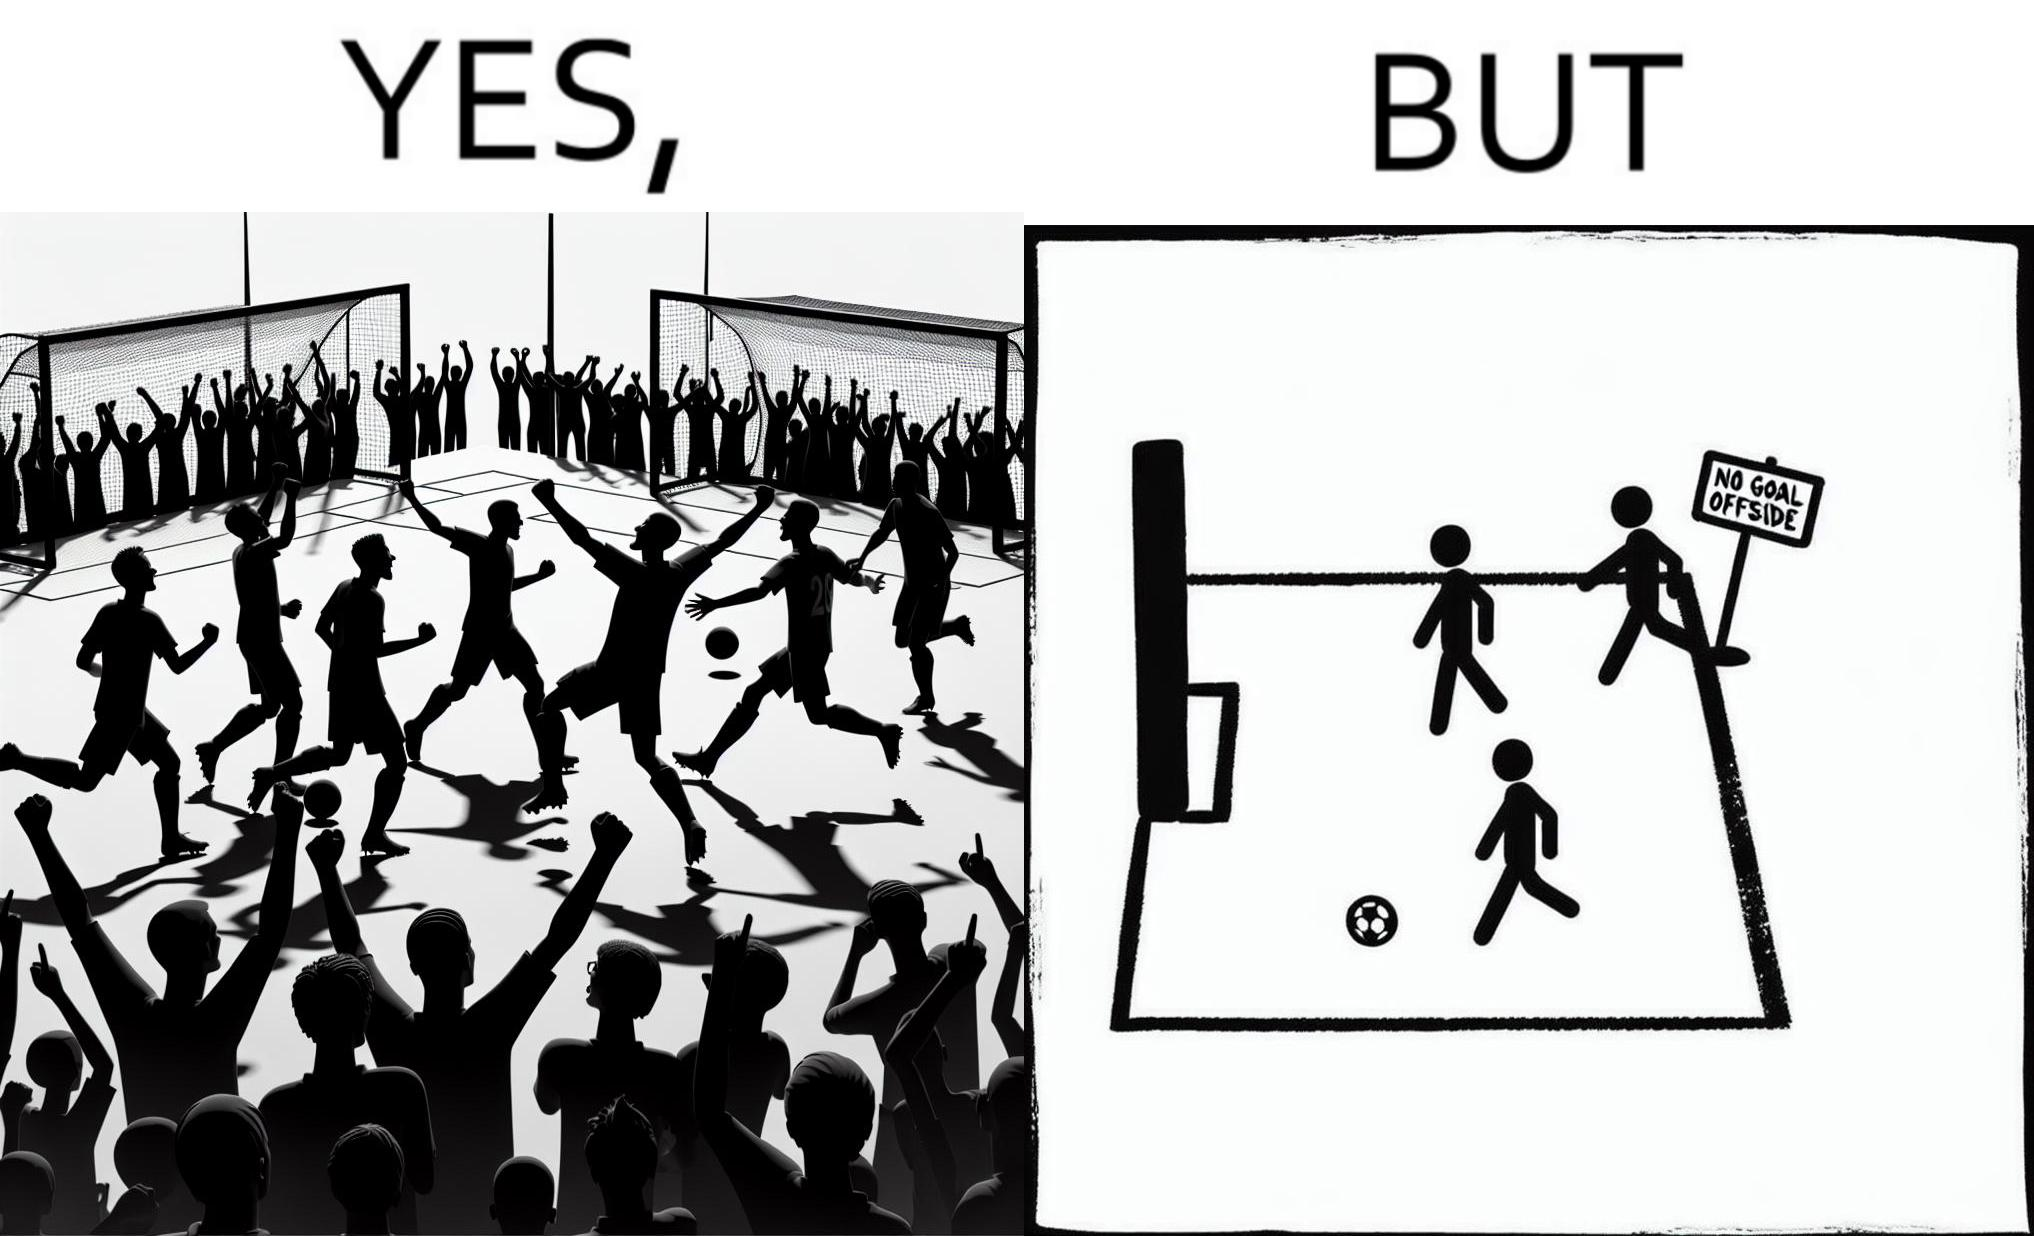Describe the contrast between the left and right parts of this image. In the left part of the image: football players celebrating, probably due a goal their team has scored. In the right part of the image: A sign of "No goal - Offside". 